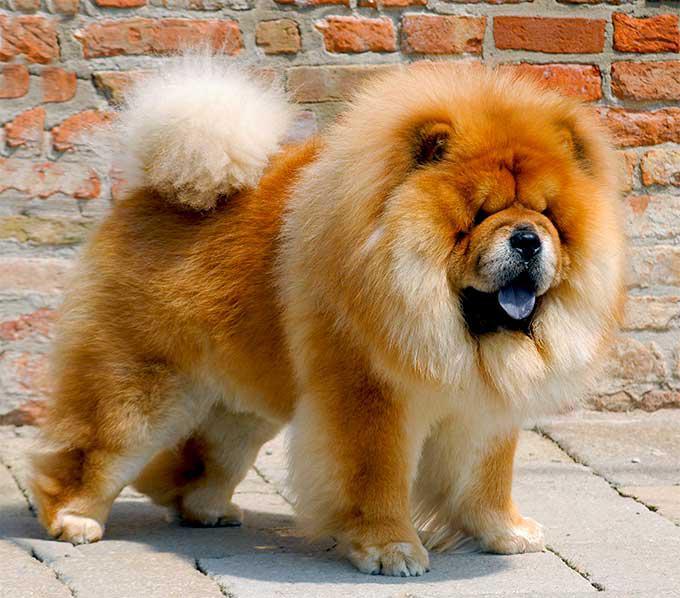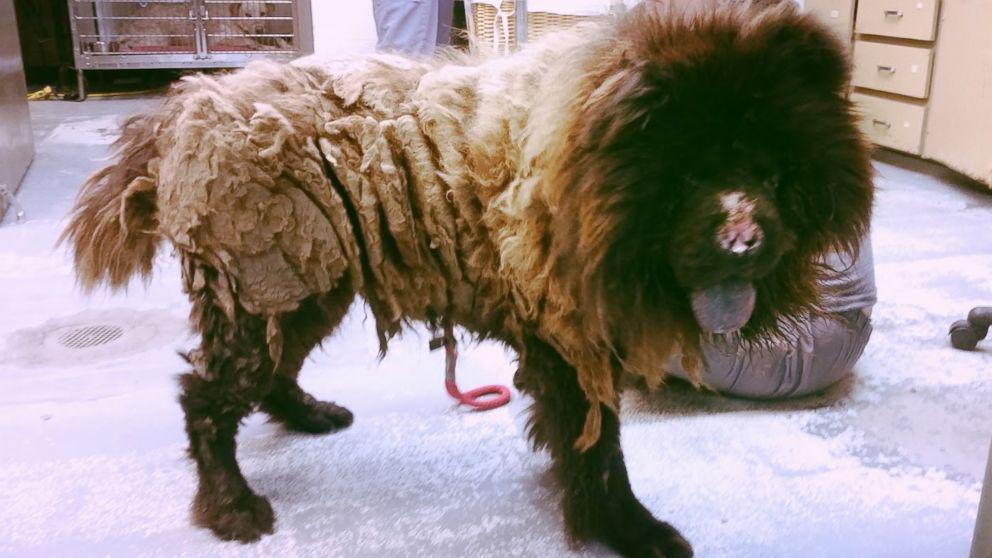The first image is the image on the left, the second image is the image on the right. Analyze the images presented: Is the assertion "The dog in the left image is orange and faces rightward." valid? Answer yes or no. Yes. The first image is the image on the left, the second image is the image on the right. Considering the images on both sides, is "There are no less than three dogs" valid? Answer yes or no. No. 